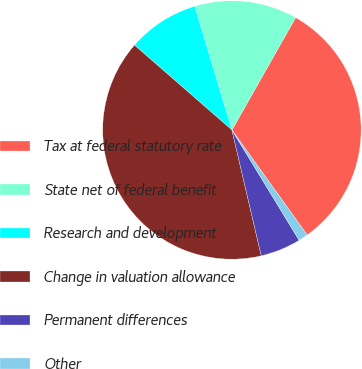Convert chart. <chart><loc_0><loc_0><loc_500><loc_500><pie_chart><fcel>Tax at federal statutory rate<fcel>State net of federal benefit<fcel>Research and development<fcel>Change in valuation allowance<fcel>Permanent differences<fcel>Other<nl><fcel>31.9%<fcel>12.84%<fcel>8.96%<fcel>40.05%<fcel>5.07%<fcel>1.18%<nl></chart> 